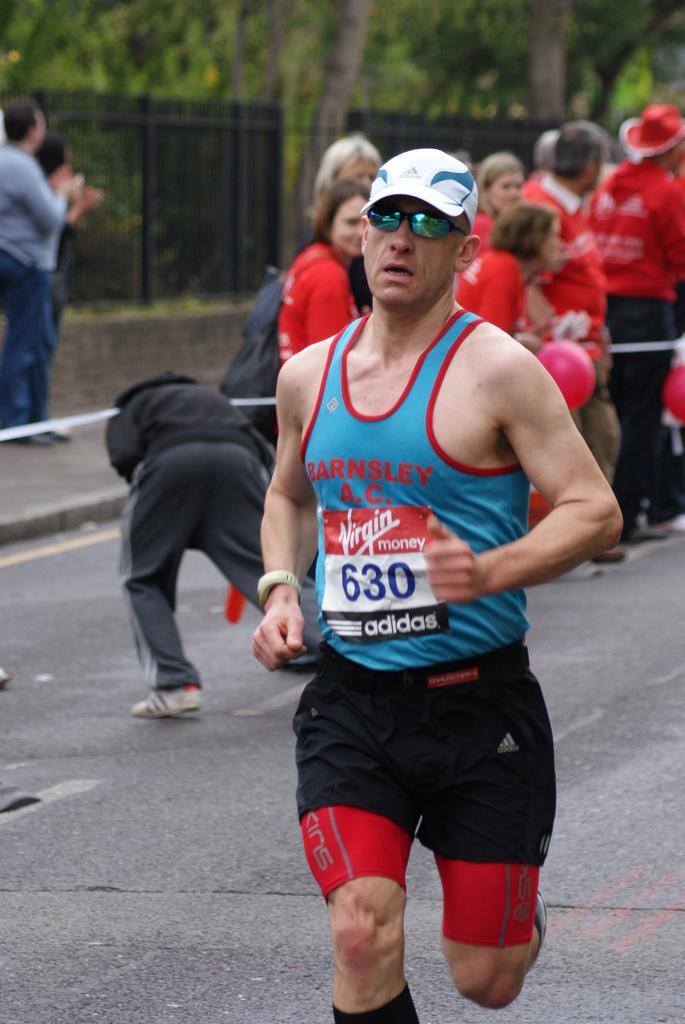Could you give a brief overview of what you see in this image? In this image I can see the person running and the person is wearing blue and black color dress. In the background I can see group of people standing and I can also see the railing and few trees in green color. 